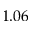<formula> <loc_0><loc_0><loc_500><loc_500>1 . 0 6</formula> 